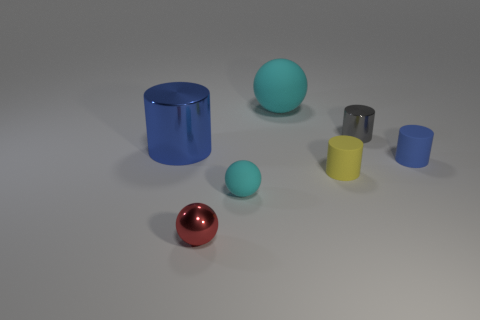Subtract all cyan balls. How many were subtracted if there are1cyan balls left? 1 Subtract 1 cylinders. How many cylinders are left? 3 Add 2 big green metallic cubes. How many objects exist? 9 Subtract all green cylinders. Subtract all green cubes. How many cylinders are left? 4 Subtract all cylinders. How many objects are left? 3 Add 4 rubber objects. How many rubber objects exist? 8 Subtract 0 green blocks. How many objects are left? 7 Subtract all tiny cyan spheres. Subtract all small blue rubber cylinders. How many objects are left? 5 Add 4 small rubber spheres. How many small rubber spheres are left? 5 